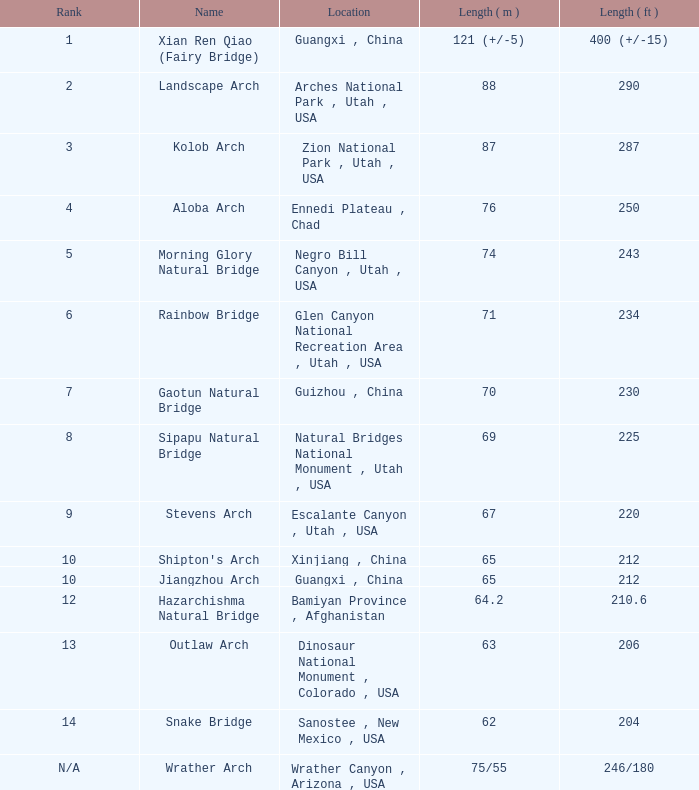Where can the 63-meter long arch, which is the longest, be found? Dinosaur National Monument , Colorado , USA. 